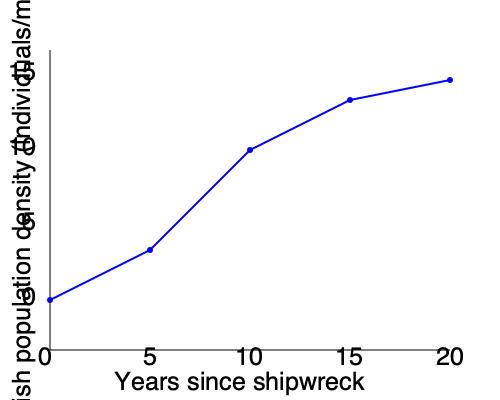Based on the line graph showing fish population density near a shipwreck over time, calculate the average rate of change in fish population density (individuals/m²/year) between years 5 and 15 after the shipwreck occurred. To calculate the average rate of change in fish population density between years 5 and 15, we need to follow these steps:

1. Identify the fish population density at year 5 and year 15:
   - At year 5 (x = 150), y ≈ 5 individuals/m²
   - At year 15 (x = 350), y ≈ 12.5 individuals/m²

2. Calculate the change in fish population density:
   $\Delta y = 12.5 - 5 = 7.5$ individuals/m²

3. Calculate the change in time:
   $\Delta x = 15 - 5 = 10$ years

4. Use the formula for average rate of change:
   Average rate of change = $\frac{\Delta y}{\Delta x}$

5. Plug in the values:
   Average rate of change = $\frac{7.5 \text{ individuals/m²}}{10 \text{ years}}$

6. Simplify:
   Average rate of change = $0.75$ individuals/m²/year

Therefore, the average rate of change in fish population density between years 5 and 15 after the shipwreck is 0.75 individuals/m²/year.
Answer: 0.75 individuals/m²/year 